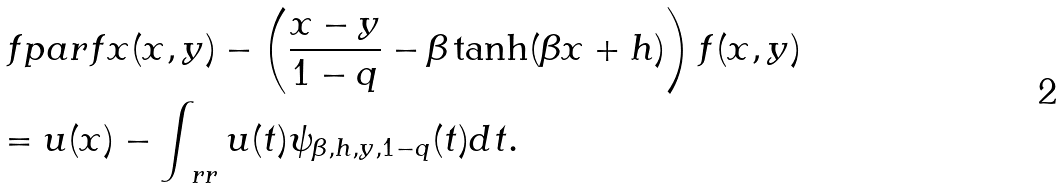Convert formula to latex. <formula><loc_0><loc_0><loc_500><loc_500>& \ f p a r { f } { x } ( x , y ) - \left ( \frac { x - y } { 1 - q } - \beta \tanh ( \beta x + h ) \right ) f ( x , y ) \\ & = u ( x ) - \int _ { \ r r } u ( t ) \psi _ { \beta , h , y , 1 - q } ( t ) d t .</formula> 